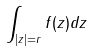Convert formula to latex. <formula><loc_0><loc_0><loc_500><loc_500>\int _ { | z | = r } f ( z ) d z</formula> 